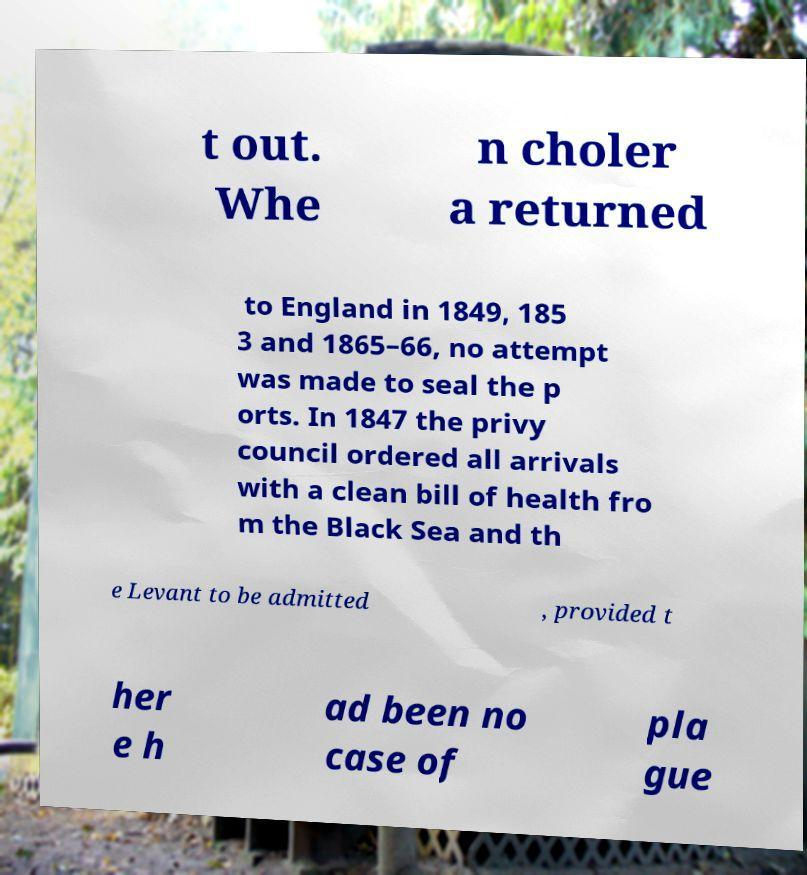There's text embedded in this image that I need extracted. Can you transcribe it verbatim? t out. Whe n choler a returned to England in 1849, 185 3 and 1865–66, no attempt was made to seal the p orts. In 1847 the privy council ordered all arrivals with a clean bill of health fro m the Black Sea and th e Levant to be admitted , provided t her e h ad been no case of pla gue 